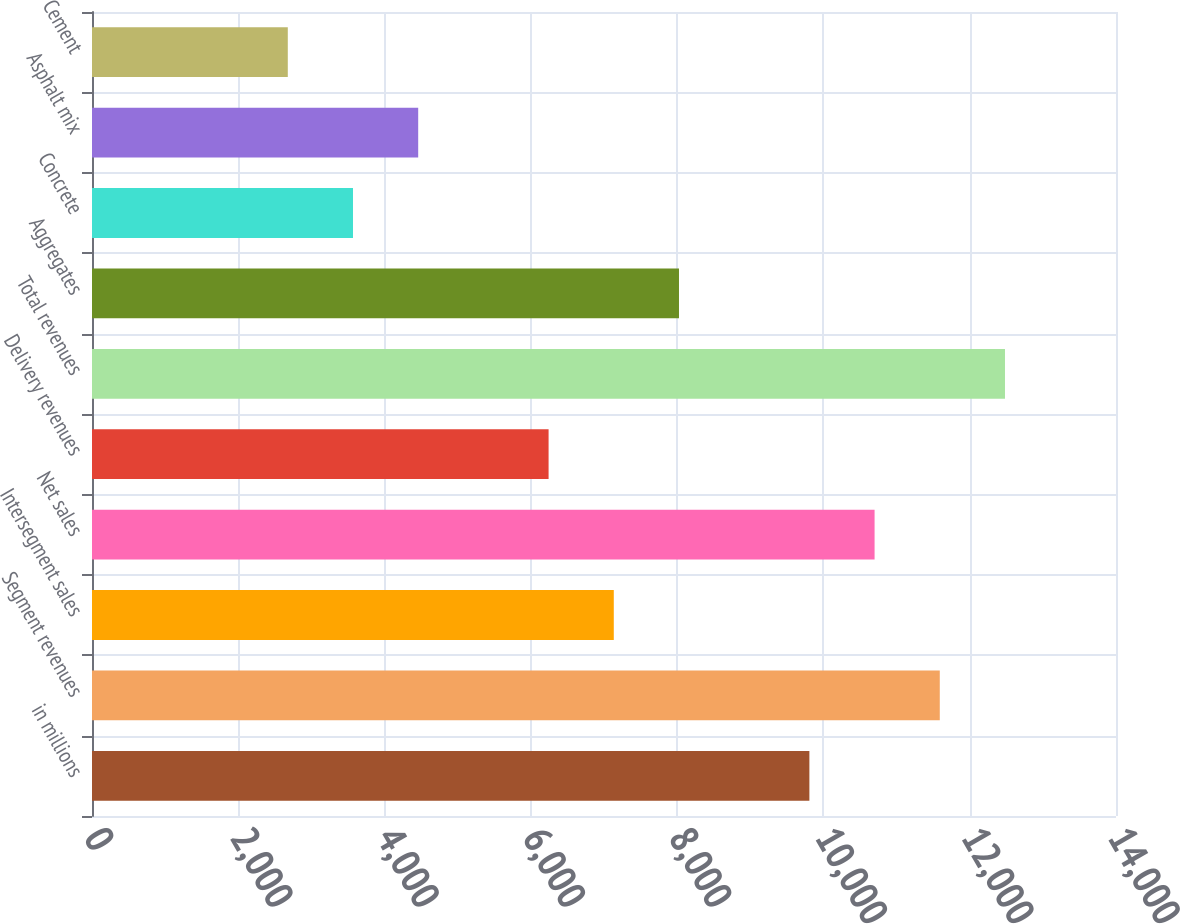Convert chart. <chart><loc_0><loc_0><loc_500><loc_500><bar_chart><fcel>in millions<fcel>Segment revenues<fcel>Intersegment sales<fcel>Net sales<fcel>Delivery revenues<fcel>Total revenues<fcel>Aggregates<fcel>Concrete<fcel>Asphalt mix<fcel>Cement<nl><fcel>9807.99<fcel>11590.8<fcel>7133.82<fcel>10699.4<fcel>6242.43<fcel>12482.2<fcel>8025.21<fcel>3568.26<fcel>4459.65<fcel>2676.87<nl></chart> 